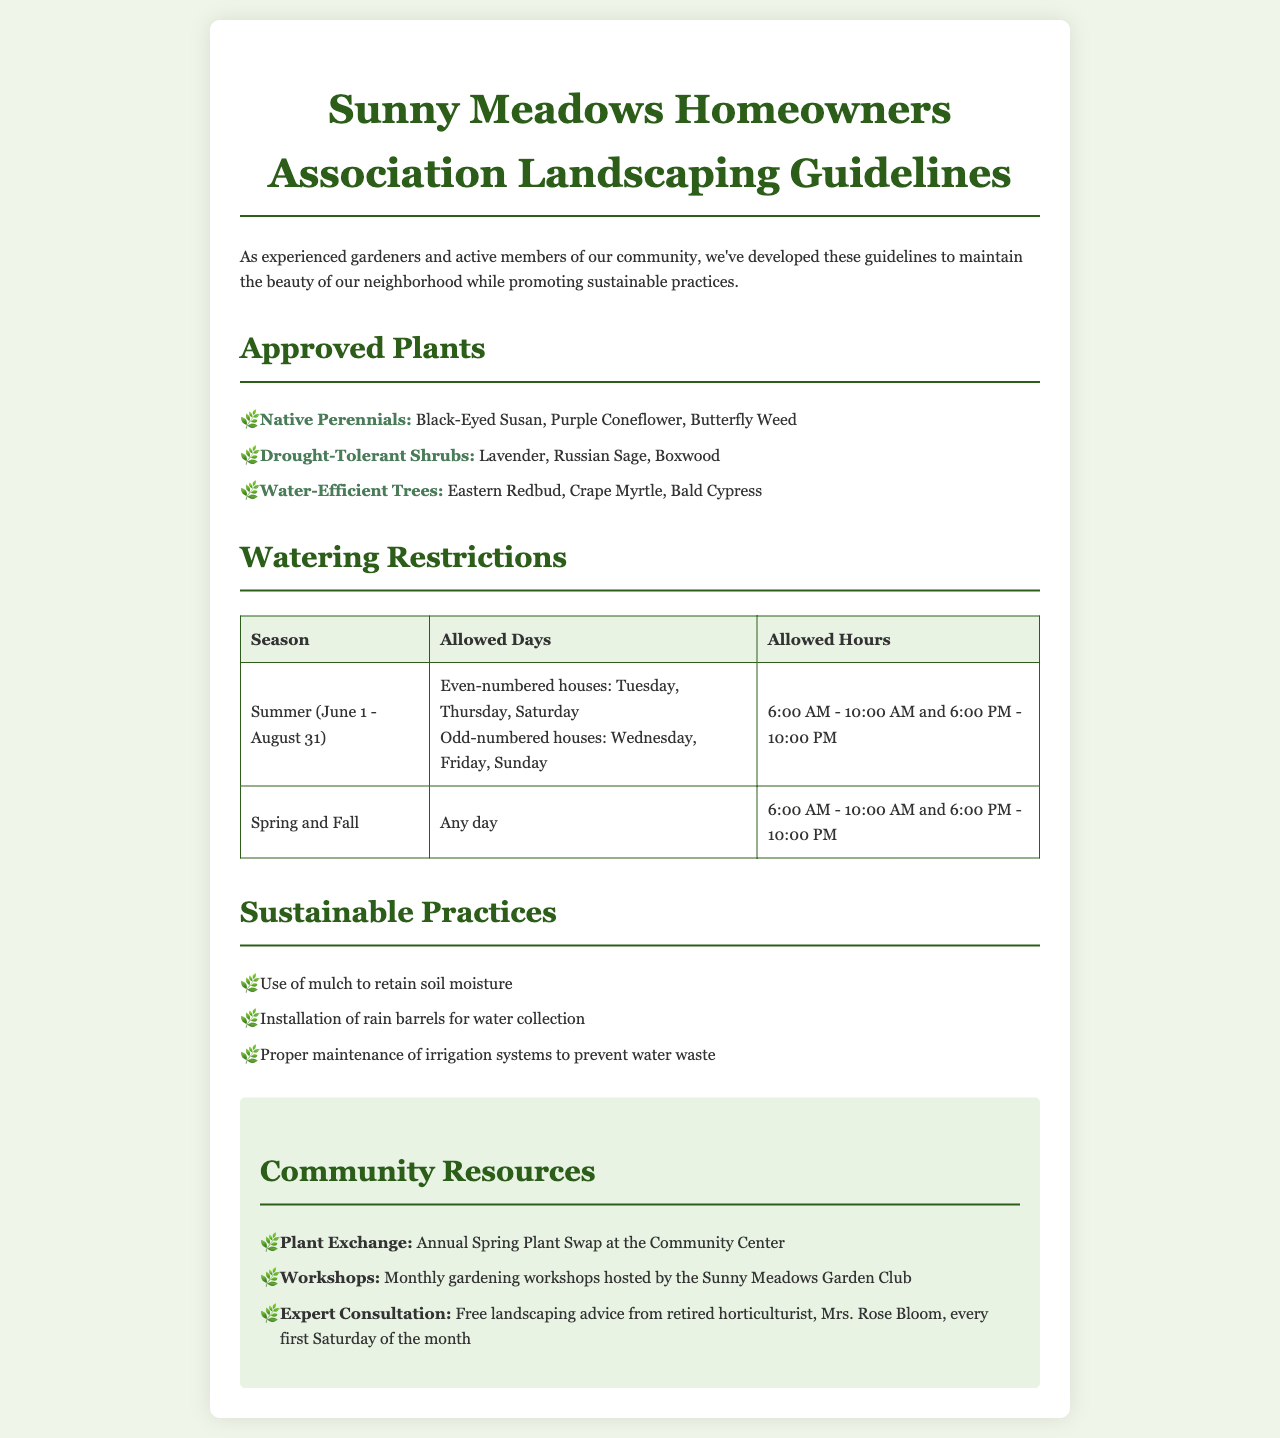What are the approved native perennials? The document lists the approved native perennials as Black-Eyed Susan, Purple Coneflower, and Butterfly Weed.
Answer: Black-Eyed Susan, Purple Coneflower, Butterfly Weed What are the allowed watering days for odd-numbered houses in summer? The document specifies that odd-numbered houses can water on Wednesday, Friday, and Sunday during the summer.
Answer: Wednesday, Friday, Sunday What time frame is allowed for watering in spring and fall? The allowed watering hours in spring and fall are stated as 6:00 AM to 10:00 AM and 6:00 PM to 10:00 PM.
Answer: 6:00 AM - 10:00 AM and 6:00 PM - 10:00 PM What type of shrubs are approved for drought-tolerance? The document mentions Lavender, Russian Sage, and Boxwood as approved drought-tolerant shrubs.
Answer: Lavender, Russian Sage, Boxwood How long is the allowed watering time during the summer? The allowed watering time for each day is from 6:00 AM to 10:00 AM and 6:00 PM to 10:00 PM, which totals 8 hours.
Answer: 8 hours What is the community resource for plant exchange? The document references the annual Spring Plant Swap at the Community Center as a community resource for plant exchange.
Answer: Annual Spring Plant Swap at the Community Center What sustainable practice is suggested for retaining soil moisture? The guidelines suggest the use of mulch as a sustainable practice to retain soil moisture.
Answer: Use of mulch Which expert offers free landscaping advice, and when? The free landscaping advice is offered by retired horticulturist Mrs. Rose Bloom every first Saturday of the month.
Answer: Mrs. Rose Bloom, every first Saturday of the month 